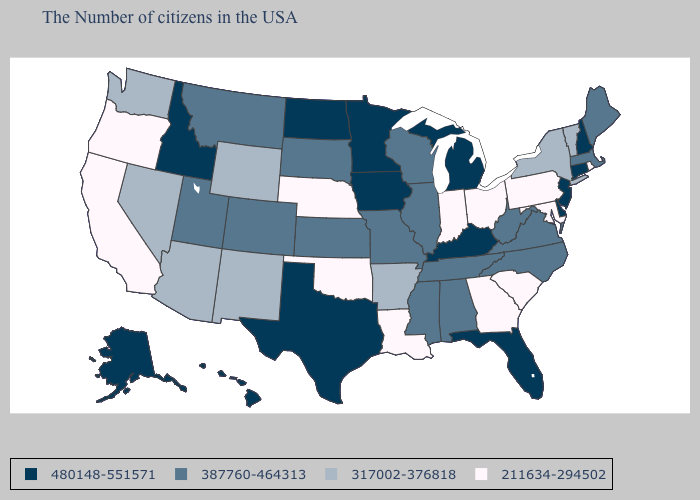Name the states that have a value in the range 387760-464313?
Be succinct. Maine, Massachusetts, Virginia, North Carolina, West Virginia, Alabama, Tennessee, Wisconsin, Illinois, Mississippi, Missouri, Kansas, South Dakota, Colorado, Utah, Montana. Does Illinois have the lowest value in the USA?
Quick response, please. No. What is the value of North Carolina?
Concise answer only. 387760-464313. Among the states that border Tennessee , which have the lowest value?
Answer briefly. Georgia. Does Missouri have the lowest value in the MidWest?
Answer briefly. No. Name the states that have a value in the range 387760-464313?
Concise answer only. Maine, Massachusetts, Virginia, North Carolina, West Virginia, Alabama, Tennessee, Wisconsin, Illinois, Mississippi, Missouri, Kansas, South Dakota, Colorado, Utah, Montana. Which states have the lowest value in the MidWest?
Concise answer only. Ohio, Indiana, Nebraska. Does Delaware have the same value as South Carolina?
Concise answer only. No. What is the value of Delaware?
Quick response, please. 480148-551571. Among the states that border Missouri , does Oklahoma have the highest value?
Answer briefly. No. Name the states that have a value in the range 211634-294502?
Write a very short answer. Rhode Island, Maryland, Pennsylvania, South Carolina, Ohio, Georgia, Indiana, Louisiana, Nebraska, Oklahoma, California, Oregon. Is the legend a continuous bar?
Quick response, please. No. Is the legend a continuous bar?
Short answer required. No. What is the value of Colorado?
Quick response, please. 387760-464313. Does North Dakota have the same value as New Jersey?
Be succinct. Yes. 